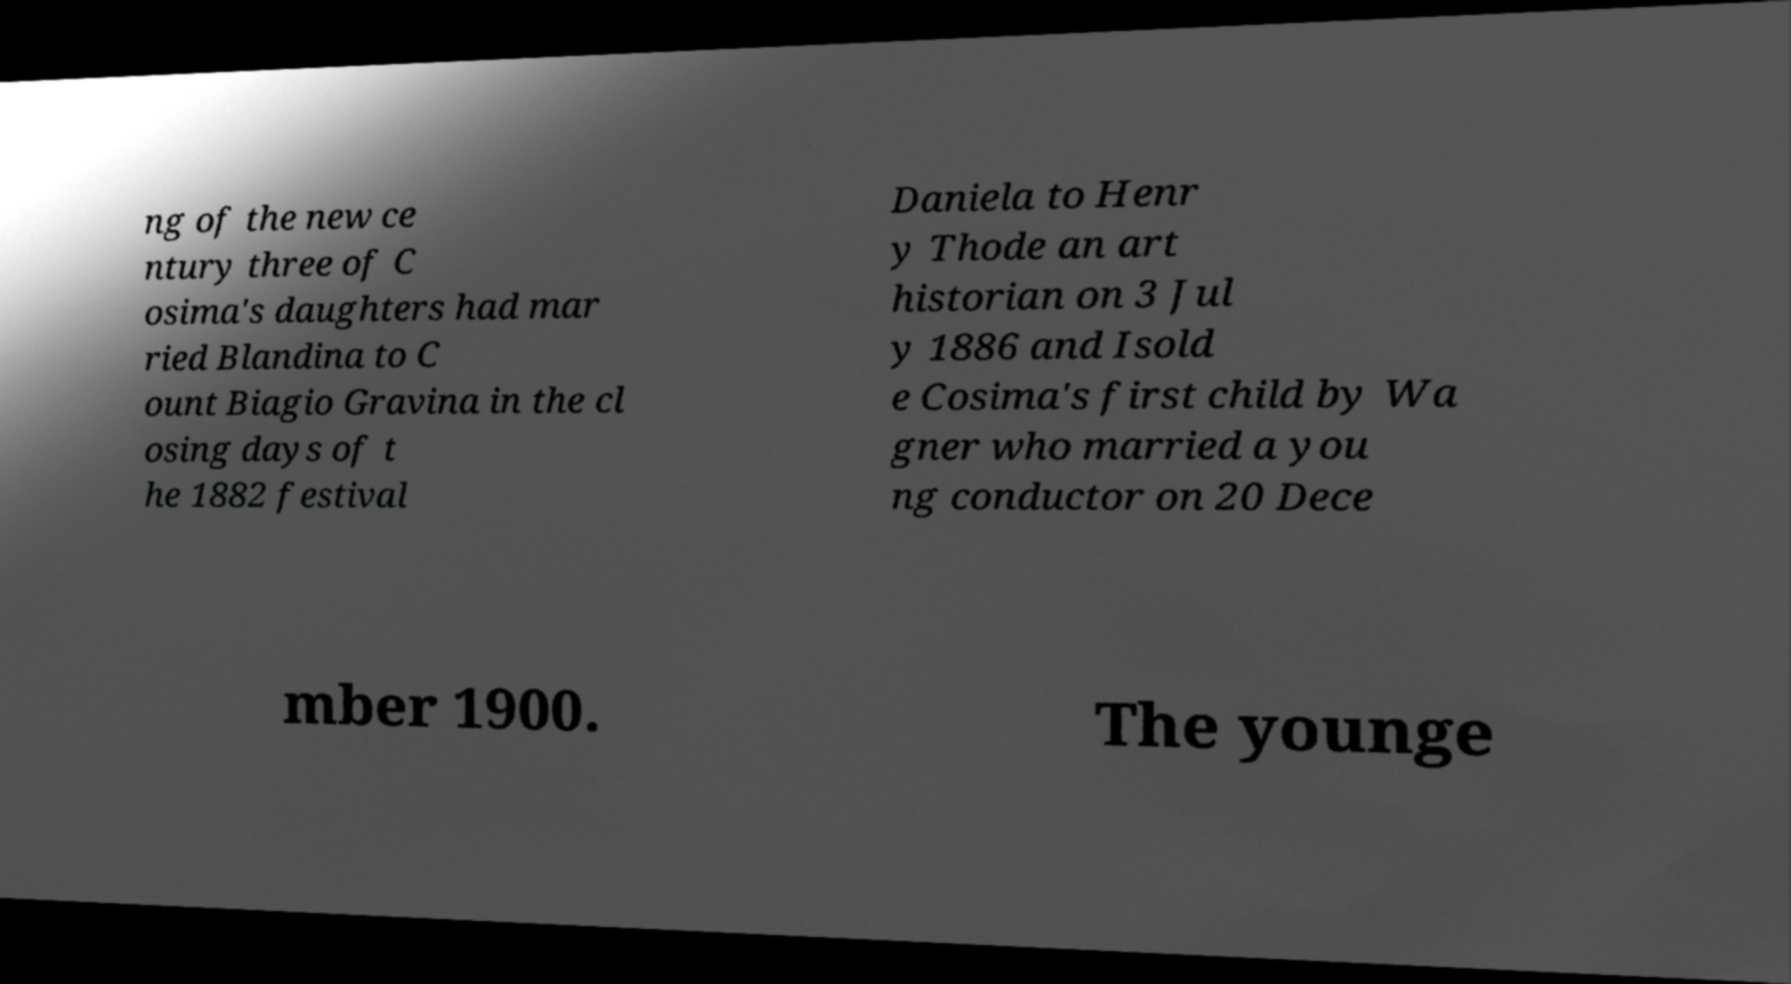Can you accurately transcribe the text from the provided image for me? ng of the new ce ntury three of C osima's daughters had mar ried Blandina to C ount Biagio Gravina in the cl osing days of t he 1882 festival Daniela to Henr y Thode an art historian on 3 Jul y 1886 and Isold e Cosima's first child by Wa gner who married a you ng conductor on 20 Dece mber 1900. The younge 